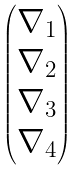Convert formula to latex. <formula><loc_0><loc_0><loc_500><loc_500>\begin{pmatrix} \nabla _ { 1 } \\ \nabla _ { 2 } \\ \nabla _ { 3 } \\ \nabla _ { 4 } \end{pmatrix}</formula> 